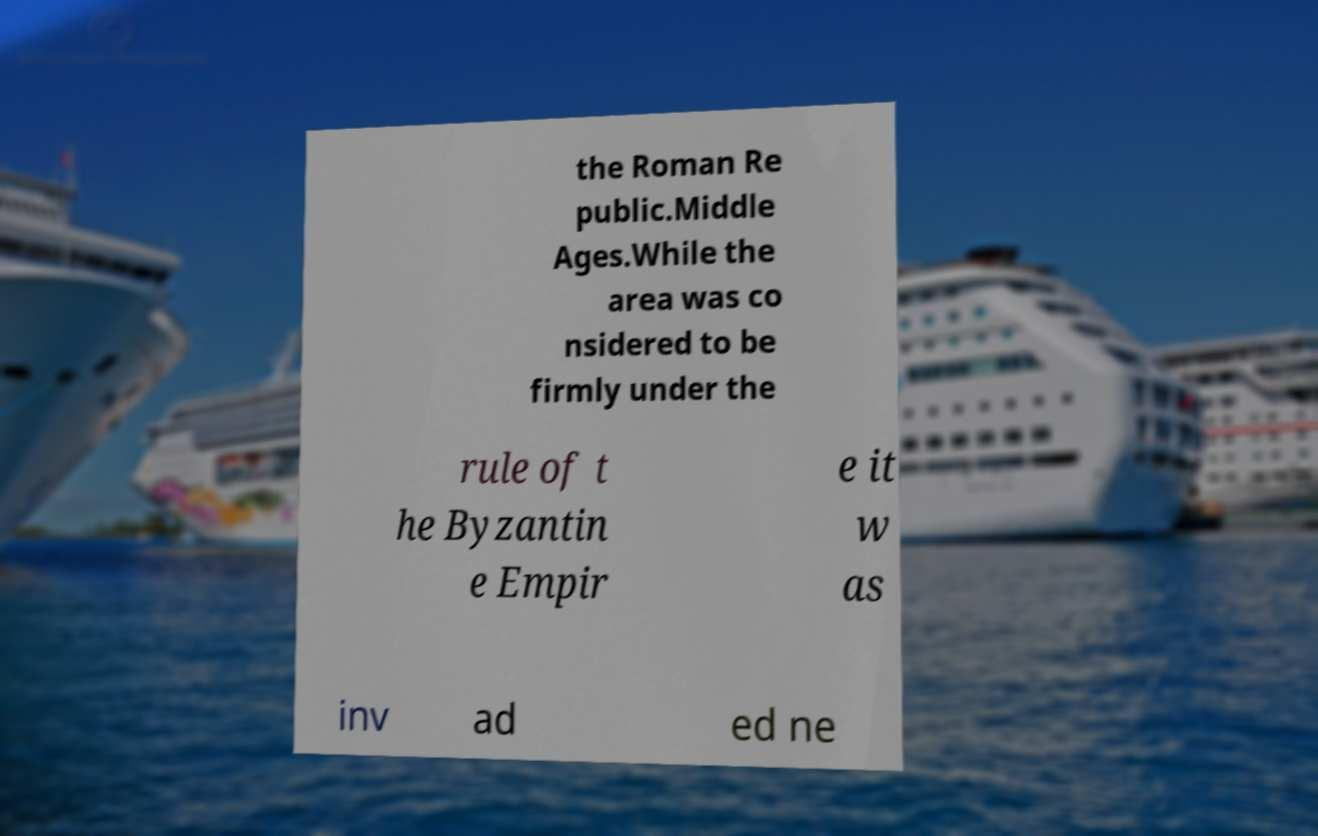Can you accurately transcribe the text from the provided image for me? the Roman Re public.Middle Ages.While the area was co nsidered to be firmly under the rule of t he Byzantin e Empir e it w as inv ad ed ne 